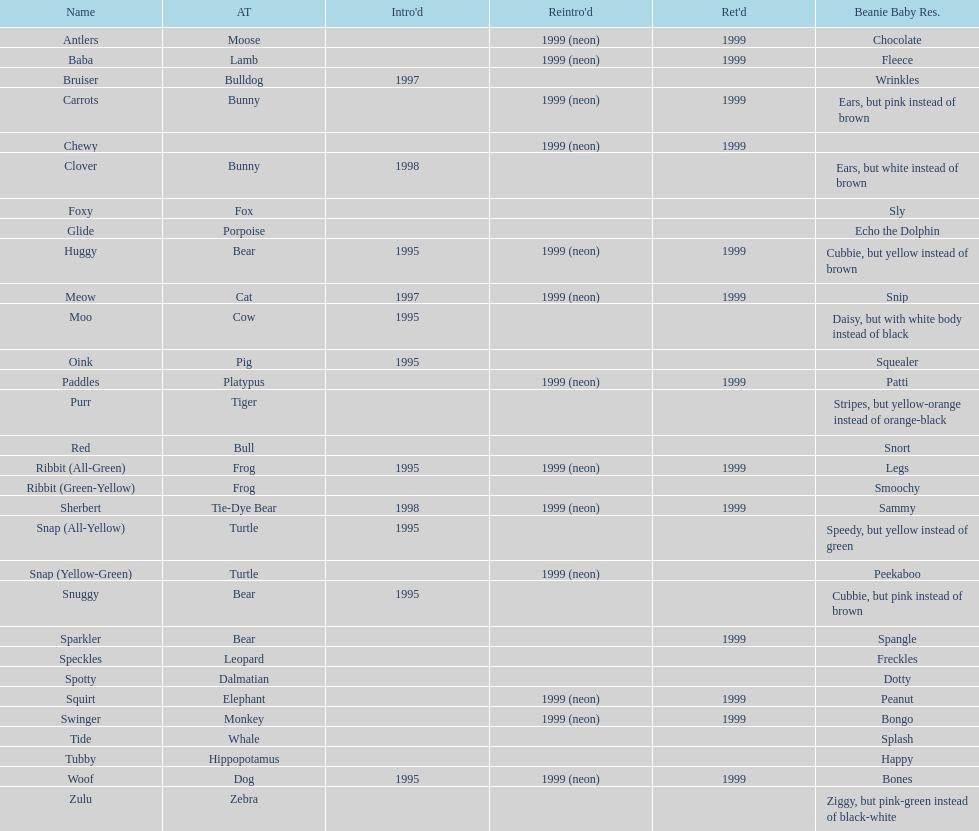What is the total number of pillow pals that were reintroduced as a neon variety? 13. 